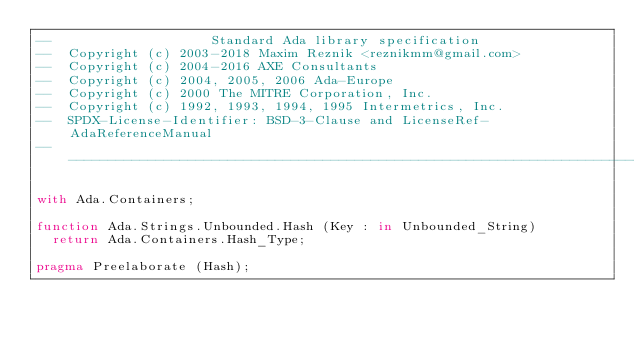<code> <loc_0><loc_0><loc_500><loc_500><_Ada_>--                    Standard Ada library specification
--  Copyright (c) 2003-2018 Maxim Reznik <reznikmm@gmail.com>
--  Copyright (c) 2004-2016 AXE Consultants
--  Copyright (c) 2004, 2005, 2006 Ada-Europe
--  Copyright (c) 2000 The MITRE Corporation, Inc.
--  Copyright (c) 1992, 1993, 1994, 1995 Intermetrics, Inc.
--  SPDX-License-Identifier: BSD-3-Clause and LicenseRef-AdaReferenceManual
---------------------------------------------------------------------------

with Ada.Containers;

function Ada.Strings.Unbounded.Hash (Key : in Unbounded_String)
  return Ada.Containers.Hash_Type;

pragma Preelaborate (Hash);
</code> 